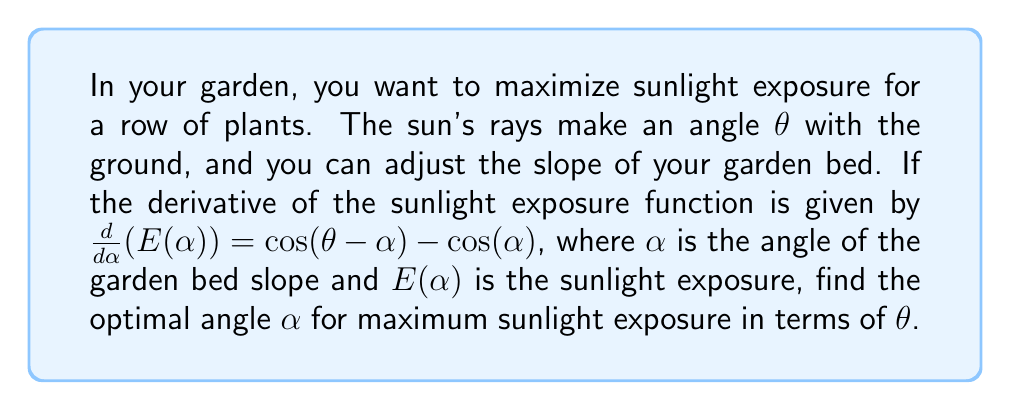Show me your answer to this math problem. 1) To find the maximum sunlight exposure, we need to find where the derivative equals zero:

   $$\frac{d}{d\alpha}(E(\alpha)) = \cos(\theta - \alpha) - \cos(\alpha) = 0$$

2) Solve the equation:
   $$\cos(\theta - \alpha) = \cos(\alpha)$$

3) This equation is true when the arguments of cosine are equal or supplementary. Since we're dealing with angles in a physical context, we can assume they're equal:

   $$\theta - \alpha = \alpha$$

4) Solve for $\alpha$:
   $$\theta = 2\alpha$$
   $$\alpha = \frac{\theta}{2}$$

5) To confirm this is a maximum (not a minimum), we can check the second derivative:

   $$\frac{d^2}{d\alpha^2}(E(\alpha)) = \sin(\theta - \alpha) - (-\sin(\alpha)) = \sin(\theta - \alpha) + \sin(\alpha)$$

   At $\alpha = \frac{\theta}{2}$, this becomes:
   $$\sin(\frac{\theta}{2}) + \sin(\frac{\theta}{2}) = 2\sin(\frac{\theta}{2})$$

   Which is positive for $0 < \theta < \pi$, confirming a maximum.

Therefore, the optimal angle for the garden bed slope is half the angle of the sun's rays with the ground.
Answer: $\alpha = \frac{\theta}{2}$ 